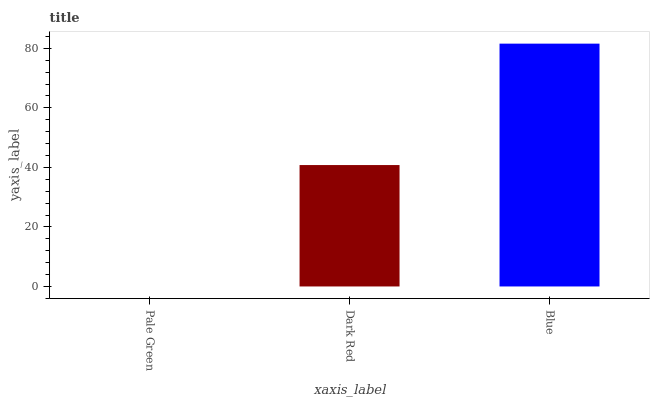Is Pale Green the minimum?
Answer yes or no. Yes. Is Blue the maximum?
Answer yes or no. Yes. Is Dark Red the minimum?
Answer yes or no. No. Is Dark Red the maximum?
Answer yes or no. No. Is Dark Red greater than Pale Green?
Answer yes or no. Yes. Is Pale Green less than Dark Red?
Answer yes or no. Yes. Is Pale Green greater than Dark Red?
Answer yes or no. No. Is Dark Red less than Pale Green?
Answer yes or no. No. Is Dark Red the high median?
Answer yes or no. Yes. Is Dark Red the low median?
Answer yes or no. Yes. Is Pale Green the high median?
Answer yes or no. No. Is Blue the low median?
Answer yes or no. No. 